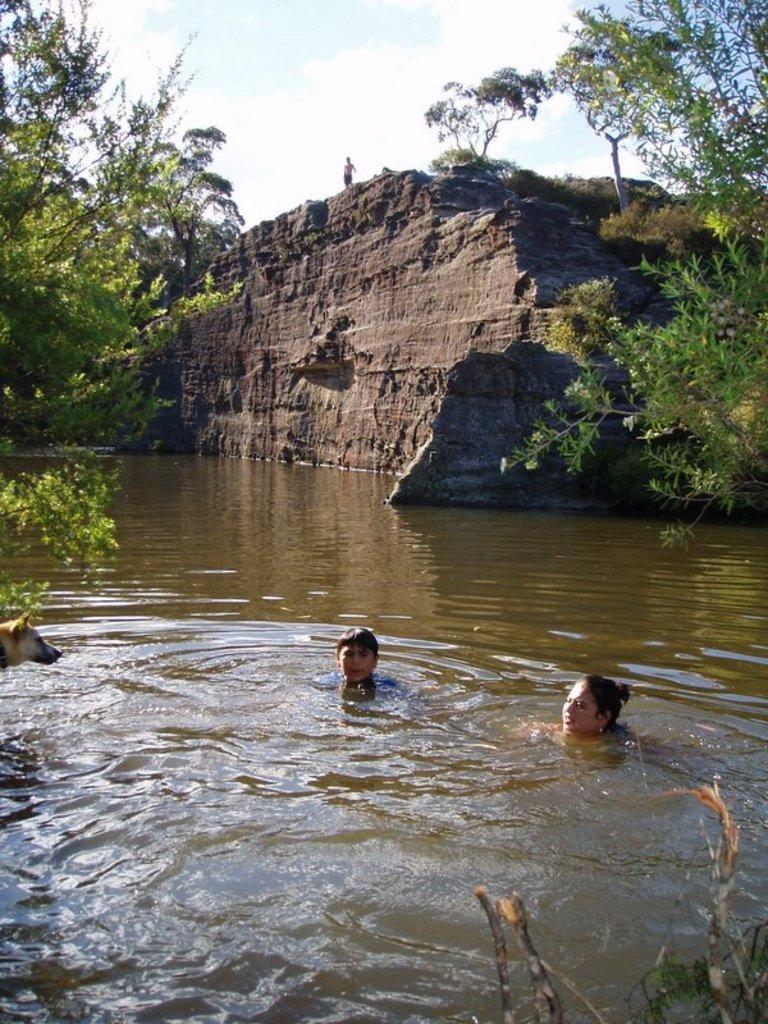Describe this image in one or two sentences. In this image, we can see two persons in the water. There is a dog on the left side of the image. There are trees in the top left and in the top right of the image. There is a rock hill in the middle of the image. At the top of the image, we can see the sky. 